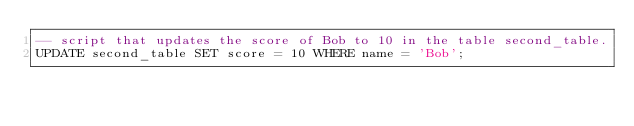Convert code to text. <code><loc_0><loc_0><loc_500><loc_500><_SQL_>-- script that updates the score of Bob to 10 in the table second_table.
UPDATE second_table SET score = 10 WHERE name = 'Bob';</code> 